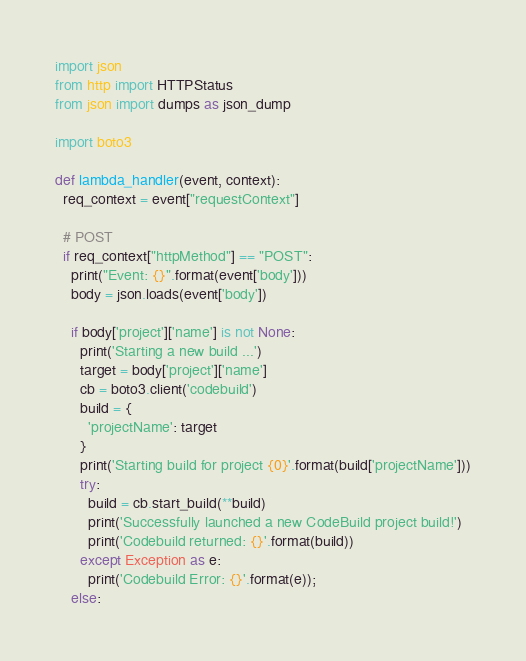<code> <loc_0><loc_0><loc_500><loc_500><_Python_>import json
from http import HTTPStatus
from json import dumps as json_dump

import boto3

def lambda_handler(event, context):
  req_context = event["requestContext"]
  
  # POST
  if req_context["httpMethod"] == "POST":
    print("Event: {}".format(event['body']))
    body = json.loads(event['body'])
    
    if body['project']['name'] is not None:
      print('Starting a new build ...')
      target = body['project']['name']
      cb = boto3.client('codebuild')
      build = {
        'projectName': target
      }
      print('Starting build for project {0}'.format(build['projectName']))
      try:
        build = cb.start_build(**build)
        print('Successfully launched a new CodeBuild project build!')
        print('Codebuild returned: {}'.format(build))
      except Exception as e:
        print('Codebuild Error: {}'.format(e));
    else:</code> 